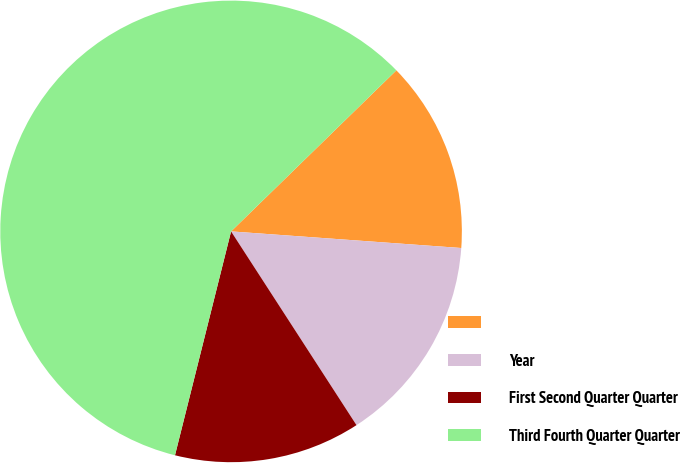Convert chart. <chart><loc_0><loc_0><loc_500><loc_500><pie_chart><ecel><fcel>Year<fcel>First Second Quarter Quarter<fcel>Third Fourth Quarter Quarter<nl><fcel>13.44%<fcel>14.71%<fcel>13.05%<fcel>58.8%<nl></chart> 